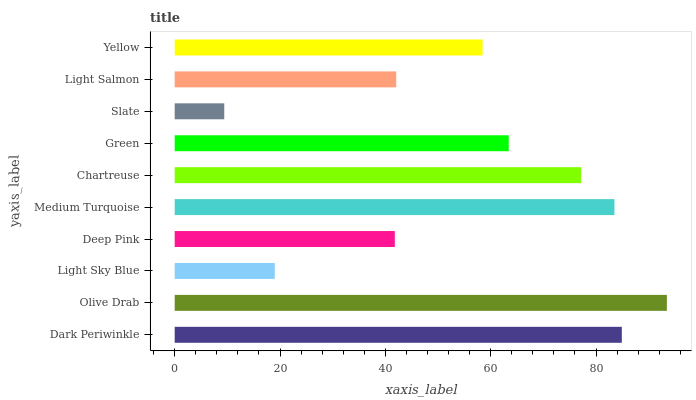Is Slate the minimum?
Answer yes or no. Yes. Is Olive Drab the maximum?
Answer yes or no. Yes. Is Light Sky Blue the minimum?
Answer yes or no. No. Is Light Sky Blue the maximum?
Answer yes or no. No. Is Olive Drab greater than Light Sky Blue?
Answer yes or no. Yes. Is Light Sky Blue less than Olive Drab?
Answer yes or no. Yes. Is Light Sky Blue greater than Olive Drab?
Answer yes or no. No. Is Olive Drab less than Light Sky Blue?
Answer yes or no. No. Is Green the high median?
Answer yes or no. Yes. Is Yellow the low median?
Answer yes or no. Yes. Is Yellow the high median?
Answer yes or no. No. Is Chartreuse the low median?
Answer yes or no. No. 